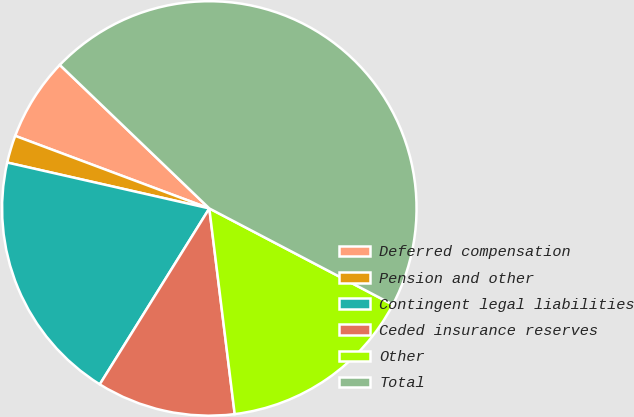Convert chart to OTSL. <chart><loc_0><loc_0><loc_500><loc_500><pie_chart><fcel>Deferred compensation<fcel>Pension and other<fcel>Contingent legal liabilities<fcel>Ceded insurance reserves<fcel>Other<fcel>Total<nl><fcel>6.48%<fcel>2.14%<fcel>19.69%<fcel>10.82%<fcel>15.36%<fcel>45.51%<nl></chart> 